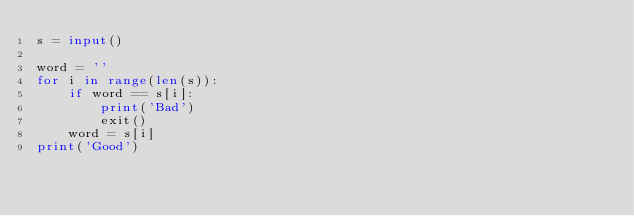<code> <loc_0><loc_0><loc_500><loc_500><_Python_>s = input()

word = ''
for i in range(len(s)):
    if word == s[i]:
        print('Bad')
        exit()
    word = s[i]
print('Good')</code> 